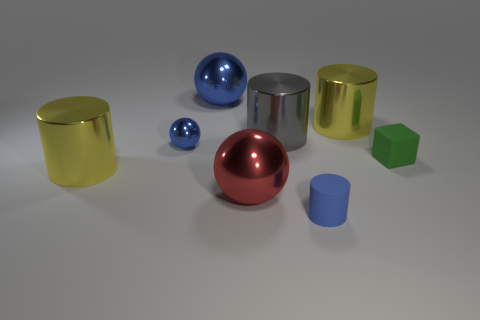Add 2 blue rubber objects. How many objects exist? 10 Subtract 0 red cylinders. How many objects are left? 8 Subtract all cubes. How many objects are left? 7 Subtract all big metal things. Subtract all rubber cylinders. How many objects are left? 2 Add 4 small balls. How many small balls are left? 5 Add 6 yellow metallic things. How many yellow metallic things exist? 8 